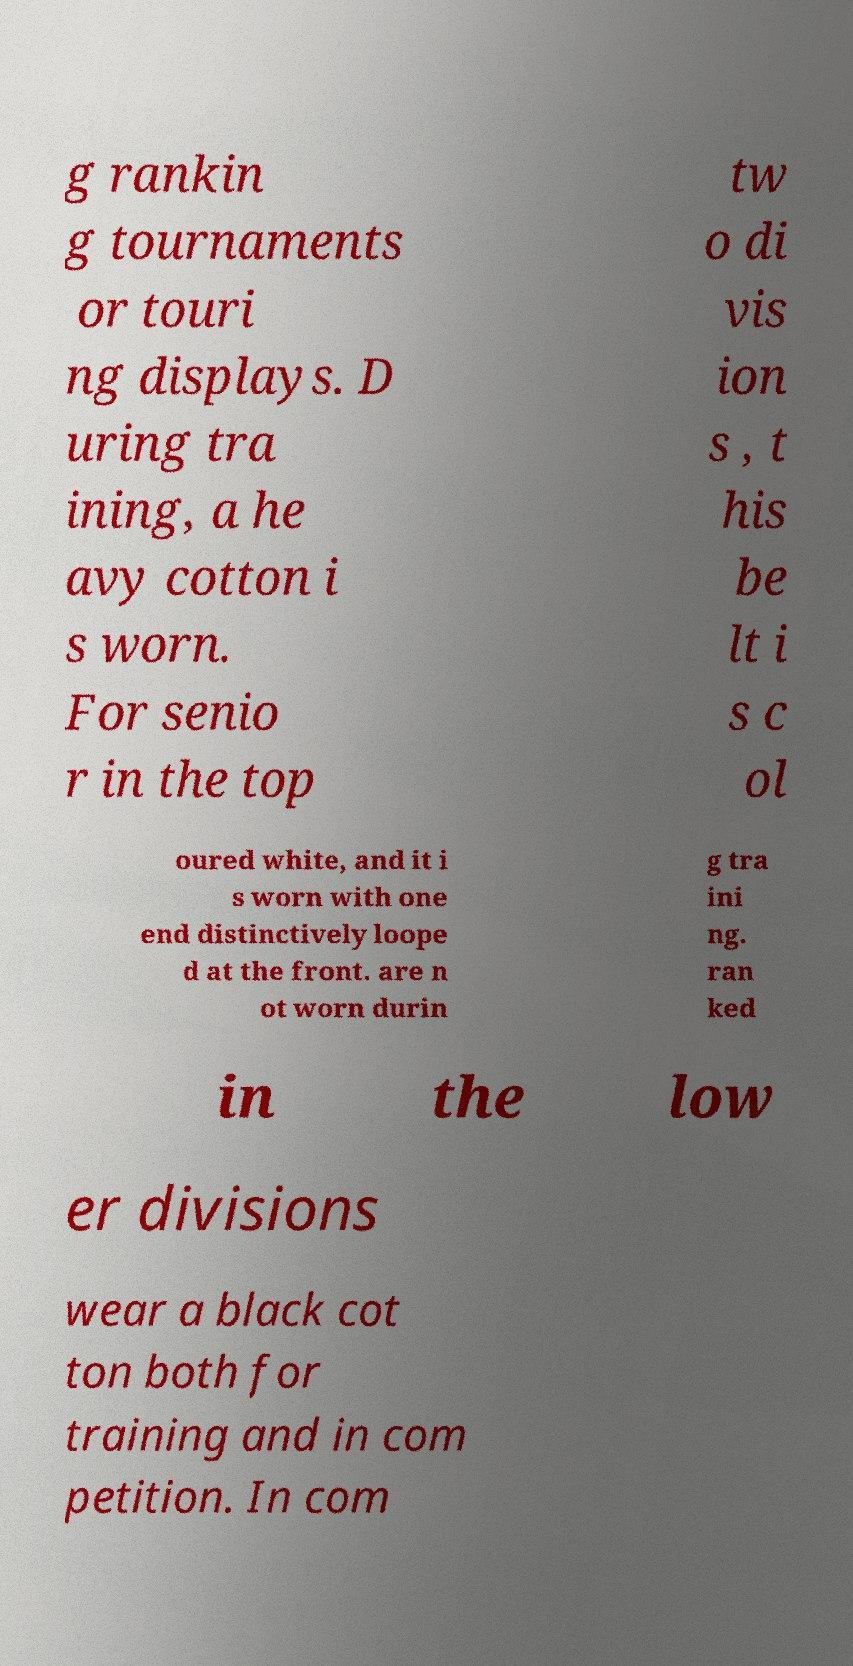Could you extract and type out the text from this image? g rankin g tournaments or touri ng displays. D uring tra ining, a he avy cotton i s worn. For senio r in the top tw o di vis ion s , t his be lt i s c ol oured white, and it i s worn with one end distinctively loope d at the front. are n ot worn durin g tra ini ng. ran ked in the low er divisions wear a black cot ton both for training and in com petition. In com 